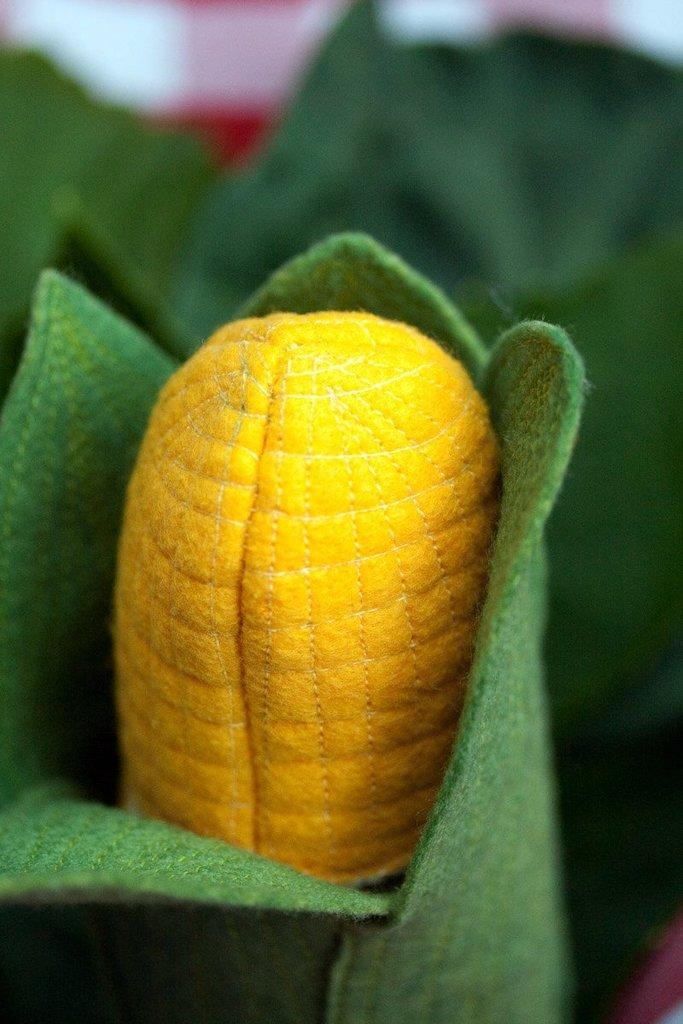How would you summarize this image in a sentence or two? In this image, we can see a craft. Here we can see can see maize and leaves. Background there is a blur view. 